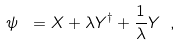Convert formula to latex. <formula><loc_0><loc_0><loc_500><loc_500>\psi \ = X + \lambda Y ^ { \dagger } + \frac { 1 } { \lambda } Y \ ,</formula> 